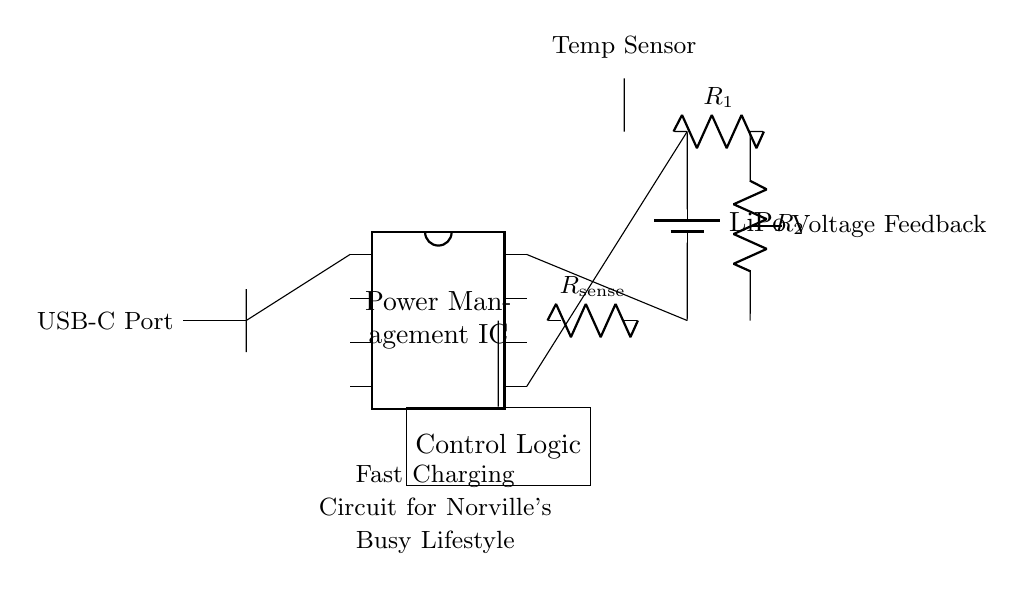What component manages power in this circuit? The component that manages power in this circuit is the Power Management IC, which is depicted in the diagram as a dipchip with multiple pins.
Answer: Power Management IC What is the type of battery used? The battery used in this circuit is a Lithium Polymer battery, indicated by the label next to the battery symbol in the diagram.
Answer: LiPo How many pins does the Power Management IC have? The Power Management IC has eight pins, which is shown in the diagram where the IC is drawn with eight distinct connection points.
Answer: Eight What does the resistor labeled R sense measure? The resistor labeled R sense measures the current flowing through the circuit by providing a voltage drop that is proportional to that current.
Answer: Current What is the role of the voltage divider in the circuit? The voltage divider, consisting of resistors R1 and R2, is used to create a feedback voltage that can be processed by the control logic to regulate the charging process.
Answer: Feedback voltage How does the temperature sensor contribute to the circuit? The temperature sensor monitors the temperature of the battery or related components, providing critical data to the control logic to prevent overheating during charging.
Answer: Overheating prevention 